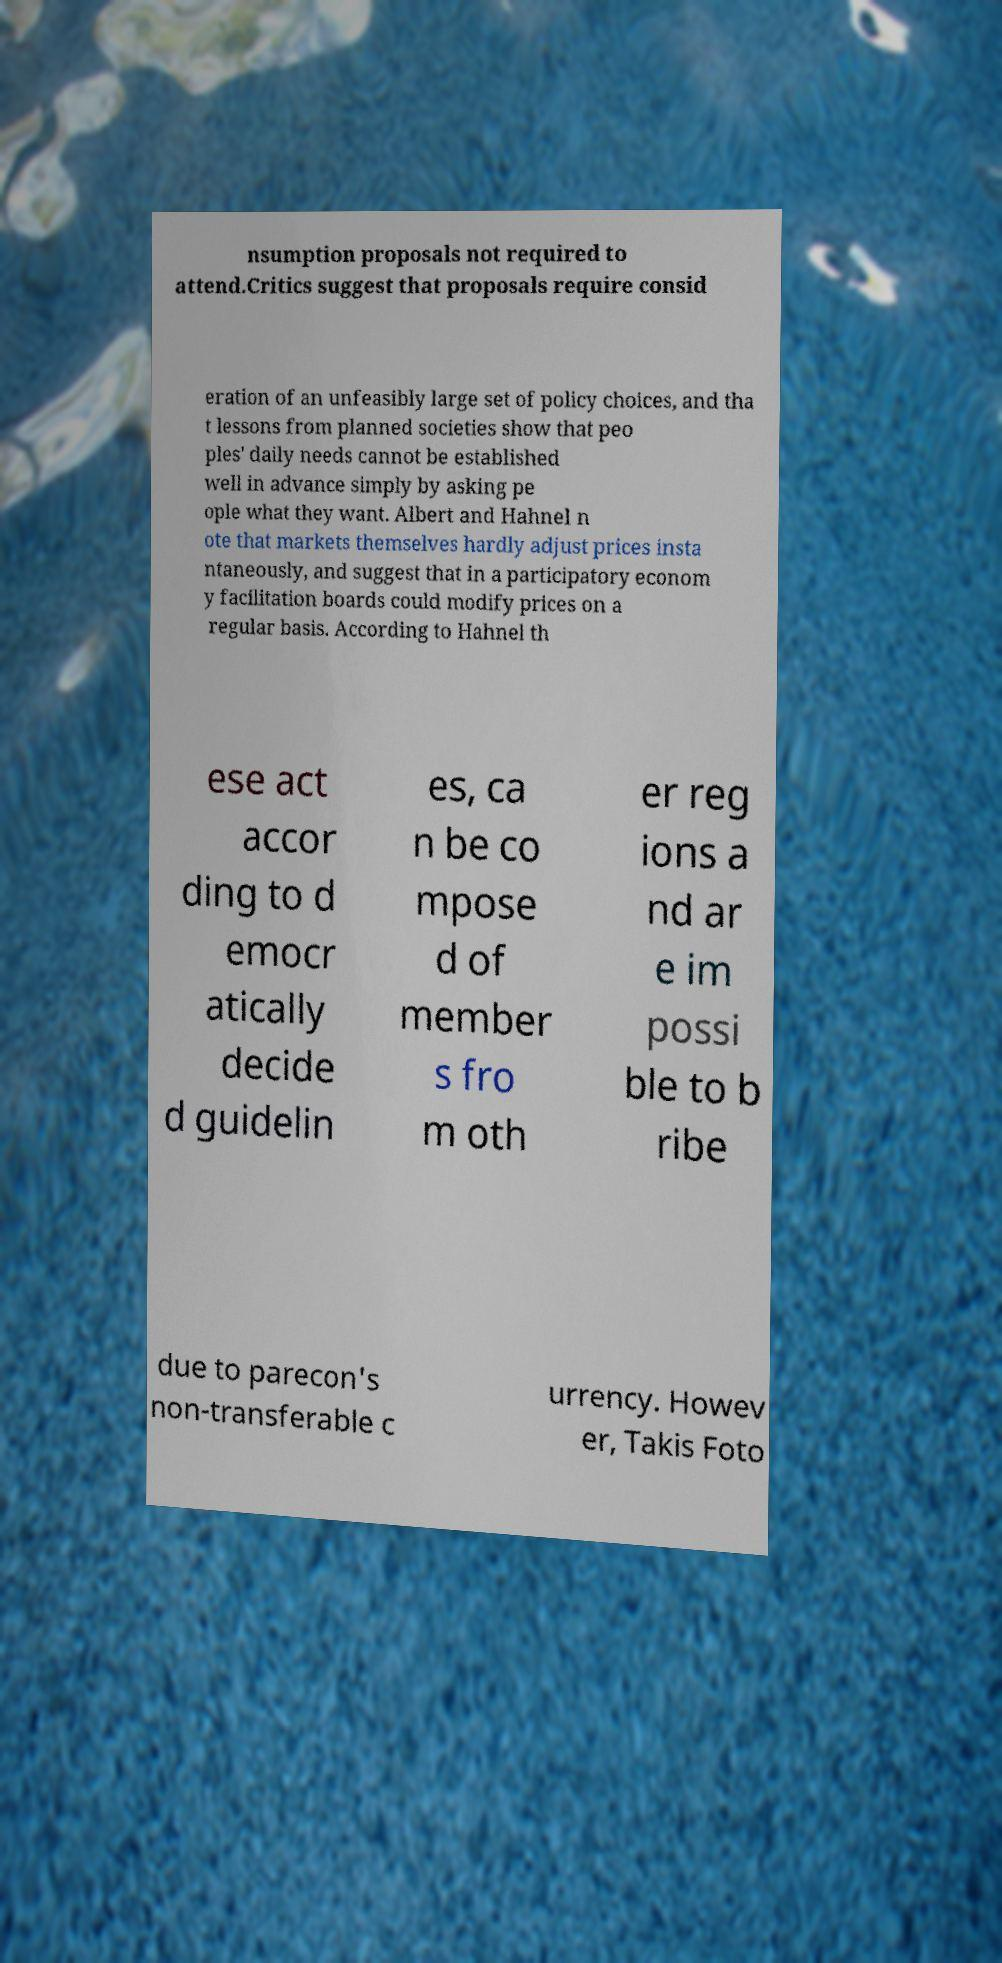Could you assist in decoding the text presented in this image and type it out clearly? nsumption proposals not required to attend.Critics suggest that proposals require consid eration of an unfeasibly large set of policy choices, and tha t lessons from planned societies show that peo ples' daily needs cannot be established well in advance simply by asking pe ople what they want. Albert and Hahnel n ote that markets themselves hardly adjust prices insta ntaneously, and suggest that in a participatory econom y facilitation boards could modify prices on a regular basis. According to Hahnel th ese act accor ding to d emocr atically decide d guidelin es, ca n be co mpose d of member s fro m oth er reg ions a nd ar e im possi ble to b ribe due to parecon's non-transferable c urrency. Howev er, Takis Foto 